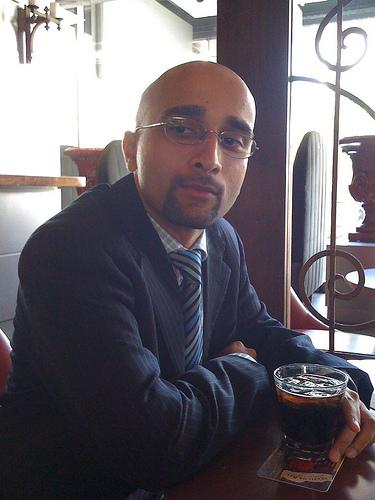Question: why is the man drinking?
Choices:
A. He's sick.
B. For pleasure.
C. To get drunk.
D. Thirsty.
Answer with the letter. Answer: D 